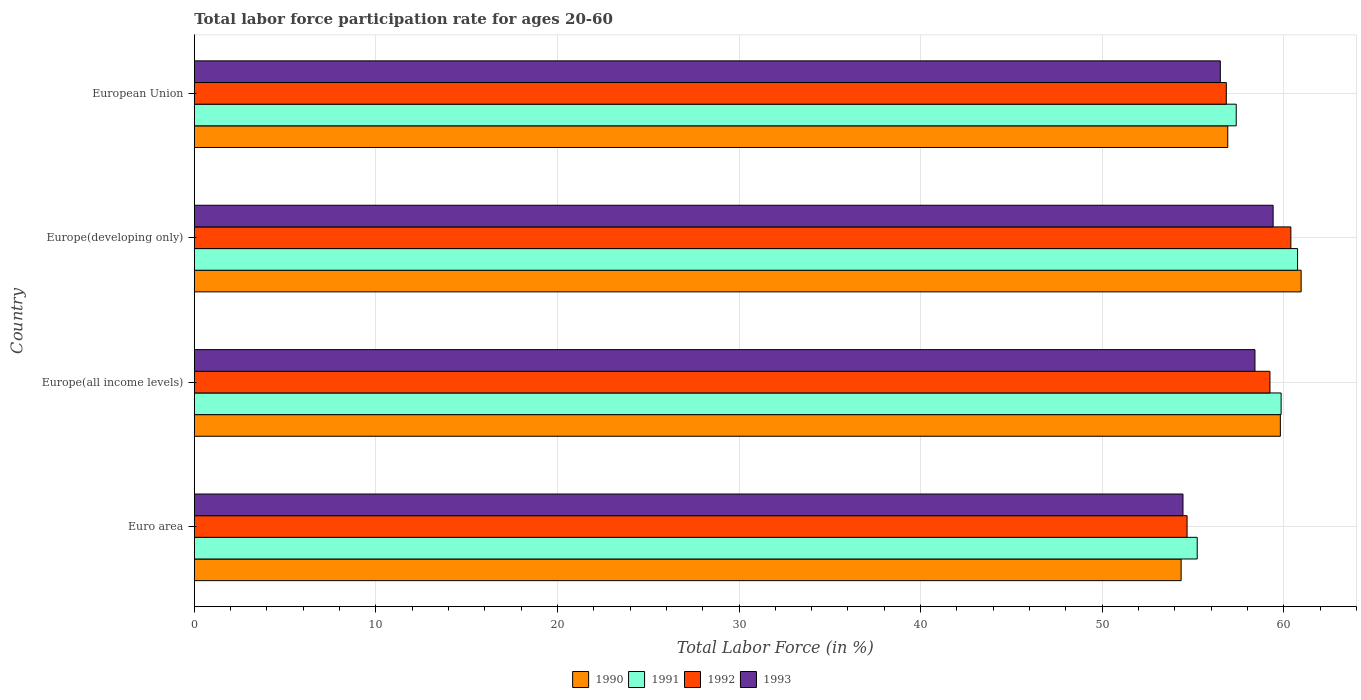Are the number of bars per tick equal to the number of legend labels?
Your response must be concise. Yes. How many bars are there on the 4th tick from the bottom?
Ensure brevity in your answer.  4. What is the label of the 3rd group of bars from the top?
Offer a very short reply. Europe(all income levels). What is the labor force participation rate in 1990 in Europe(all income levels)?
Ensure brevity in your answer.  59.82. Across all countries, what is the maximum labor force participation rate in 1991?
Make the answer very short. 60.76. Across all countries, what is the minimum labor force participation rate in 1991?
Keep it short and to the point. 55.24. In which country was the labor force participation rate in 1992 maximum?
Offer a very short reply. Europe(developing only). What is the total labor force participation rate in 1991 in the graph?
Offer a terse response. 233.24. What is the difference between the labor force participation rate in 1992 in Europe(all income levels) and that in European Union?
Your response must be concise. 2.4. What is the difference between the labor force participation rate in 1991 in Euro area and the labor force participation rate in 1993 in Europe(all income levels)?
Keep it short and to the point. -3.18. What is the average labor force participation rate in 1990 per country?
Keep it short and to the point. 58.01. What is the difference between the labor force participation rate in 1991 and labor force participation rate in 1990 in Euro area?
Provide a succinct answer. 0.89. What is the ratio of the labor force participation rate in 1991 in Euro area to that in Europe(developing only)?
Provide a succinct answer. 0.91. What is the difference between the highest and the second highest labor force participation rate in 1993?
Your answer should be very brief. 1. What is the difference between the highest and the lowest labor force participation rate in 1991?
Your response must be concise. 5.53. In how many countries, is the labor force participation rate in 1991 greater than the average labor force participation rate in 1991 taken over all countries?
Your response must be concise. 2. What does the 2nd bar from the bottom in Europe(all income levels) represents?
Offer a terse response. 1991. How many countries are there in the graph?
Your answer should be very brief. 4. What is the difference between two consecutive major ticks on the X-axis?
Offer a very short reply. 10. Does the graph contain any zero values?
Give a very brief answer. No. How many legend labels are there?
Offer a terse response. 4. What is the title of the graph?
Provide a succinct answer. Total labor force participation rate for ages 20-60. What is the label or title of the X-axis?
Your answer should be very brief. Total Labor Force (in %). What is the label or title of the Y-axis?
Offer a terse response. Country. What is the Total Labor Force (in %) in 1990 in Euro area?
Your answer should be very brief. 54.35. What is the Total Labor Force (in %) in 1991 in Euro area?
Your answer should be very brief. 55.24. What is the Total Labor Force (in %) of 1992 in Euro area?
Your response must be concise. 54.68. What is the Total Labor Force (in %) of 1993 in Euro area?
Provide a short and direct response. 54.45. What is the Total Labor Force (in %) in 1990 in Europe(all income levels)?
Offer a terse response. 59.82. What is the Total Labor Force (in %) of 1991 in Europe(all income levels)?
Offer a terse response. 59.86. What is the Total Labor Force (in %) of 1992 in Europe(all income levels)?
Offer a very short reply. 59.24. What is the Total Labor Force (in %) of 1993 in Europe(all income levels)?
Provide a short and direct response. 58.42. What is the Total Labor Force (in %) in 1990 in Europe(developing only)?
Your response must be concise. 60.96. What is the Total Labor Force (in %) of 1991 in Europe(developing only)?
Keep it short and to the point. 60.76. What is the Total Labor Force (in %) of 1992 in Europe(developing only)?
Your answer should be compact. 60.39. What is the Total Labor Force (in %) of 1993 in Europe(developing only)?
Offer a very short reply. 59.42. What is the Total Labor Force (in %) of 1990 in European Union?
Your response must be concise. 56.92. What is the Total Labor Force (in %) in 1991 in European Union?
Your answer should be very brief. 57.38. What is the Total Labor Force (in %) of 1992 in European Union?
Provide a short and direct response. 56.84. What is the Total Labor Force (in %) of 1993 in European Union?
Provide a succinct answer. 56.51. Across all countries, what is the maximum Total Labor Force (in %) in 1990?
Offer a terse response. 60.96. Across all countries, what is the maximum Total Labor Force (in %) of 1991?
Make the answer very short. 60.76. Across all countries, what is the maximum Total Labor Force (in %) of 1992?
Offer a terse response. 60.39. Across all countries, what is the maximum Total Labor Force (in %) in 1993?
Provide a succinct answer. 59.42. Across all countries, what is the minimum Total Labor Force (in %) of 1990?
Provide a short and direct response. 54.35. Across all countries, what is the minimum Total Labor Force (in %) of 1991?
Ensure brevity in your answer.  55.24. Across all countries, what is the minimum Total Labor Force (in %) in 1992?
Keep it short and to the point. 54.68. Across all countries, what is the minimum Total Labor Force (in %) of 1993?
Provide a succinct answer. 54.45. What is the total Total Labor Force (in %) in 1990 in the graph?
Ensure brevity in your answer.  232.04. What is the total Total Labor Force (in %) in 1991 in the graph?
Your response must be concise. 233.24. What is the total Total Labor Force (in %) in 1992 in the graph?
Offer a very short reply. 231.15. What is the total Total Labor Force (in %) of 1993 in the graph?
Give a very brief answer. 228.79. What is the difference between the Total Labor Force (in %) of 1990 in Euro area and that in Europe(all income levels)?
Your answer should be compact. -5.46. What is the difference between the Total Labor Force (in %) in 1991 in Euro area and that in Europe(all income levels)?
Make the answer very short. -4.62. What is the difference between the Total Labor Force (in %) of 1992 in Euro area and that in Europe(all income levels)?
Offer a terse response. -4.56. What is the difference between the Total Labor Force (in %) in 1993 in Euro area and that in Europe(all income levels)?
Give a very brief answer. -3.96. What is the difference between the Total Labor Force (in %) of 1990 in Euro area and that in Europe(developing only)?
Your response must be concise. -6.61. What is the difference between the Total Labor Force (in %) of 1991 in Euro area and that in Europe(developing only)?
Keep it short and to the point. -5.53. What is the difference between the Total Labor Force (in %) of 1992 in Euro area and that in Europe(developing only)?
Offer a very short reply. -5.72. What is the difference between the Total Labor Force (in %) in 1993 in Euro area and that in Europe(developing only)?
Offer a terse response. -4.96. What is the difference between the Total Labor Force (in %) in 1990 in Euro area and that in European Union?
Your response must be concise. -2.57. What is the difference between the Total Labor Force (in %) in 1991 in Euro area and that in European Union?
Ensure brevity in your answer.  -2.15. What is the difference between the Total Labor Force (in %) of 1992 in Euro area and that in European Union?
Provide a short and direct response. -2.16. What is the difference between the Total Labor Force (in %) of 1993 in Euro area and that in European Union?
Keep it short and to the point. -2.06. What is the difference between the Total Labor Force (in %) in 1990 in Europe(all income levels) and that in Europe(developing only)?
Ensure brevity in your answer.  -1.14. What is the difference between the Total Labor Force (in %) of 1991 in Europe(all income levels) and that in Europe(developing only)?
Give a very brief answer. -0.91. What is the difference between the Total Labor Force (in %) in 1992 in Europe(all income levels) and that in Europe(developing only)?
Your response must be concise. -1.15. What is the difference between the Total Labor Force (in %) of 1993 in Europe(all income levels) and that in Europe(developing only)?
Give a very brief answer. -1. What is the difference between the Total Labor Force (in %) of 1990 in Europe(all income levels) and that in European Union?
Provide a short and direct response. 2.9. What is the difference between the Total Labor Force (in %) of 1991 in Europe(all income levels) and that in European Union?
Ensure brevity in your answer.  2.47. What is the difference between the Total Labor Force (in %) of 1992 in Europe(all income levels) and that in European Union?
Make the answer very short. 2.4. What is the difference between the Total Labor Force (in %) of 1993 in Europe(all income levels) and that in European Union?
Ensure brevity in your answer.  1.91. What is the difference between the Total Labor Force (in %) of 1990 in Europe(developing only) and that in European Union?
Offer a very short reply. 4.04. What is the difference between the Total Labor Force (in %) of 1991 in Europe(developing only) and that in European Union?
Offer a very short reply. 3.38. What is the difference between the Total Labor Force (in %) of 1992 in Europe(developing only) and that in European Union?
Your answer should be very brief. 3.56. What is the difference between the Total Labor Force (in %) in 1993 in Europe(developing only) and that in European Union?
Your response must be concise. 2.91. What is the difference between the Total Labor Force (in %) in 1990 in Euro area and the Total Labor Force (in %) in 1991 in Europe(all income levels)?
Offer a very short reply. -5.51. What is the difference between the Total Labor Force (in %) in 1990 in Euro area and the Total Labor Force (in %) in 1992 in Europe(all income levels)?
Ensure brevity in your answer.  -4.89. What is the difference between the Total Labor Force (in %) of 1990 in Euro area and the Total Labor Force (in %) of 1993 in Europe(all income levels)?
Give a very brief answer. -4.07. What is the difference between the Total Labor Force (in %) of 1991 in Euro area and the Total Labor Force (in %) of 1992 in Europe(all income levels)?
Make the answer very short. -4.01. What is the difference between the Total Labor Force (in %) in 1991 in Euro area and the Total Labor Force (in %) in 1993 in Europe(all income levels)?
Your response must be concise. -3.18. What is the difference between the Total Labor Force (in %) in 1992 in Euro area and the Total Labor Force (in %) in 1993 in Europe(all income levels)?
Your answer should be compact. -3.74. What is the difference between the Total Labor Force (in %) in 1990 in Euro area and the Total Labor Force (in %) in 1991 in Europe(developing only)?
Make the answer very short. -6.41. What is the difference between the Total Labor Force (in %) in 1990 in Euro area and the Total Labor Force (in %) in 1992 in Europe(developing only)?
Your response must be concise. -6.04. What is the difference between the Total Labor Force (in %) of 1990 in Euro area and the Total Labor Force (in %) of 1993 in Europe(developing only)?
Keep it short and to the point. -5.07. What is the difference between the Total Labor Force (in %) in 1991 in Euro area and the Total Labor Force (in %) in 1992 in Europe(developing only)?
Provide a short and direct response. -5.16. What is the difference between the Total Labor Force (in %) of 1991 in Euro area and the Total Labor Force (in %) of 1993 in Europe(developing only)?
Your response must be concise. -4.18. What is the difference between the Total Labor Force (in %) in 1992 in Euro area and the Total Labor Force (in %) in 1993 in Europe(developing only)?
Offer a very short reply. -4.74. What is the difference between the Total Labor Force (in %) in 1990 in Euro area and the Total Labor Force (in %) in 1991 in European Union?
Keep it short and to the point. -3.03. What is the difference between the Total Labor Force (in %) in 1990 in Euro area and the Total Labor Force (in %) in 1992 in European Union?
Offer a very short reply. -2.49. What is the difference between the Total Labor Force (in %) in 1990 in Euro area and the Total Labor Force (in %) in 1993 in European Union?
Ensure brevity in your answer.  -2.16. What is the difference between the Total Labor Force (in %) in 1991 in Euro area and the Total Labor Force (in %) in 1992 in European Union?
Offer a very short reply. -1.6. What is the difference between the Total Labor Force (in %) in 1991 in Euro area and the Total Labor Force (in %) in 1993 in European Union?
Ensure brevity in your answer.  -1.27. What is the difference between the Total Labor Force (in %) in 1992 in Euro area and the Total Labor Force (in %) in 1993 in European Union?
Your answer should be very brief. -1.83. What is the difference between the Total Labor Force (in %) in 1990 in Europe(all income levels) and the Total Labor Force (in %) in 1991 in Europe(developing only)?
Give a very brief answer. -0.95. What is the difference between the Total Labor Force (in %) of 1990 in Europe(all income levels) and the Total Labor Force (in %) of 1992 in Europe(developing only)?
Your response must be concise. -0.58. What is the difference between the Total Labor Force (in %) in 1990 in Europe(all income levels) and the Total Labor Force (in %) in 1993 in Europe(developing only)?
Ensure brevity in your answer.  0.4. What is the difference between the Total Labor Force (in %) of 1991 in Europe(all income levels) and the Total Labor Force (in %) of 1992 in Europe(developing only)?
Offer a terse response. -0.54. What is the difference between the Total Labor Force (in %) in 1991 in Europe(all income levels) and the Total Labor Force (in %) in 1993 in Europe(developing only)?
Your response must be concise. 0.44. What is the difference between the Total Labor Force (in %) in 1992 in Europe(all income levels) and the Total Labor Force (in %) in 1993 in Europe(developing only)?
Provide a succinct answer. -0.17. What is the difference between the Total Labor Force (in %) in 1990 in Europe(all income levels) and the Total Labor Force (in %) in 1991 in European Union?
Your answer should be compact. 2.43. What is the difference between the Total Labor Force (in %) of 1990 in Europe(all income levels) and the Total Labor Force (in %) of 1992 in European Union?
Your response must be concise. 2.98. What is the difference between the Total Labor Force (in %) in 1990 in Europe(all income levels) and the Total Labor Force (in %) in 1993 in European Union?
Provide a succinct answer. 3.31. What is the difference between the Total Labor Force (in %) of 1991 in Europe(all income levels) and the Total Labor Force (in %) of 1992 in European Union?
Ensure brevity in your answer.  3.02. What is the difference between the Total Labor Force (in %) in 1991 in Europe(all income levels) and the Total Labor Force (in %) in 1993 in European Union?
Your answer should be compact. 3.35. What is the difference between the Total Labor Force (in %) in 1992 in Europe(all income levels) and the Total Labor Force (in %) in 1993 in European Union?
Offer a very short reply. 2.73. What is the difference between the Total Labor Force (in %) of 1990 in Europe(developing only) and the Total Labor Force (in %) of 1991 in European Union?
Ensure brevity in your answer.  3.57. What is the difference between the Total Labor Force (in %) in 1990 in Europe(developing only) and the Total Labor Force (in %) in 1992 in European Union?
Provide a short and direct response. 4.12. What is the difference between the Total Labor Force (in %) in 1990 in Europe(developing only) and the Total Labor Force (in %) in 1993 in European Union?
Your answer should be compact. 4.45. What is the difference between the Total Labor Force (in %) in 1991 in Europe(developing only) and the Total Labor Force (in %) in 1992 in European Union?
Offer a terse response. 3.93. What is the difference between the Total Labor Force (in %) of 1991 in Europe(developing only) and the Total Labor Force (in %) of 1993 in European Union?
Your answer should be very brief. 4.25. What is the difference between the Total Labor Force (in %) of 1992 in Europe(developing only) and the Total Labor Force (in %) of 1993 in European Union?
Your answer should be very brief. 3.88. What is the average Total Labor Force (in %) in 1990 per country?
Offer a very short reply. 58.01. What is the average Total Labor Force (in %) in 1991 per country?
Make the answer very short. 58.31. What is the average Total Labor Force (in %) in 1992 per country?
Give a very brief answer. 57.79. What is the average Total Labor Force (in %) in 1993 per country?
Keep it short and to the point. 57.2. What is the difference between the Total Labor Force (in %) in 1990 and Total Labor Force (in %) in 1991 in Euro area?
Your answer should be compact. -0.89. What is the difference between the Total Labor Force (in %) of 1990 and Total Labor Force (in %) of 1992 in Euro area?
Provide a short and direct response. -0.33. What is the difference between the Total Labor Force (in %) of 1990 and Total Labor Force (in %) of 1993 in Euro area?
Your answer should be very brief. -0.1. What is the difference between the Total Labor Force (in %) of 1991 and Total Labor Force (in %) of 1992 in Euro area?
Ensure brevity in your answer.  0.56. What is the difference between the Total Labor Force (in %) in 1991 and Total Labor Force (in %) in 1993 in Euro area?
Offer a terse response. 0.78. What is the difference between the Total Labor Force (in %) in 1992 and Total Labor Force (in %) in 1993 in Euro area?
Your answer should be very brief. 0.22. What is the difference between the Total Labor Force (in %) in 1990 and Total Labor Force (in %) in 1991 in Europe(all income levels)?
Provide a succinct answer. -0.04. What is the difference between the Total Labor Force (in %) in 1990 and Total Labor Force (in %) in 1992 in Europe(all income levels)?
Ensure brevity in your answer.  0.57. What is the difference between the Total Labor Force (in %) in 1990 and Total Labor Force (in %) in 1993 in Europe(all income levels)?
Give a very brief answer. 1.4. What is the difference between the Total Labor Force (in %) in 1991 and Total Labor Force (in %) in 1992 in Europe(all income levels)?
Your answer should be compact. 0.61. What is the difference between the Total Labor Force (in %) in 1991 and Total Labor Force (in %) in 1993 in Europe(all income levels)?
Your answer should be compact. 1.44. What is the difference between the Total Labor Force (in %) in 1992 and Total Labor Force (in %) in 1993 in Europe(all income levels)?
Ensure brevity in your answer.  0.83. What is the difference between the Total Labor Force (in %) of 1990 and Total Labor Force (in %) of 1991 in Europe(developing only)?
Offer a terse response. 0.2. What is the difference between the Total Labor Force (in %) of 1990 and Total Labor Force (in %) of 1992 in Europe(developing only)?
Give a very brief answer. 0.57. What is the difference between the Total Labor Force (in %) in 1990 and Total Labor Force (in %) in 1993 in Europe(developing only)?
Make the answer very short. 1.54. What is the difference between the Total Labor Force (in %) of 1991 and Total Labor Force (in %) of 1992 in Europe(developing only)?
Provide a succinct answer. 0.37. What is the difference between the Total Labor Force (in %) of 1991 and Total Labor Force (in %) of 1993 in Europe(developing only)?
Your answer should be very brief. 1.35. What is the difference between the Total Labor Force (in %) in 1992 and Total Labor Force (in %) in 1993 in Europe(developing only)?
Give a very brief answer. 0.98. What is the difference between the Total Labor Force (in %) in 1990 and Total Labor Force (in %) in 1991 in European Union?
Provide a succinct answer. -0.47. What is the difference between the Total Labor Force (in %) in 1990 and Total Labor Force (in %) in 1992 in European Union?
Ensure brevity in your answer.  0.08. What is the difference between the Total Labor Force (in %) of 1990 and Total Labor Force (in %) of 1993 in European Union?
Offer a very short reply. 0.41. What is the difference between the Total Labor Force (in %) of 1991 and Total Labor Force (in %) of 1992 in European Union?
Provide a succinct answer. 0.55. What is the difference between the Total Labor Force (in %) in 1991 and Total Labor Force (in %) in 1993 in European Union?
Provide a short and direct response. 0.88. What is the difference between the Total Labor Force (in %) of 1992 and Total Labor Force (in %) of 1993 in European Union?
Provide a short and direct response. 0.33. What is the ratio of the Total Labor Force (in %) of 1990 in Euro area to that in Europe(all income levels)?
Offer a terse response. 0.91. What is the ratio of the Total Labor Force (in %) of 1991 in Euro area to that in Europe(all income levels)?
Offer a very short reply. 0.92. What is the ratio of the Total Labor Force (in %) of 1992 in Euro area to that in Europe(all income levels)?
Your response must be concise. 0.92. What is the ratio of the Total Labor Force (in %) of 1993 in Euro area to that in Europe(all income levels)?
Your answer should be very brief. 0.93. What is the ratio of the Total Labor Force (in %) in 1990 in Euro area to that in Europe(developing only)?
Your answer should be compact. 0.89. What is the ratio of the Total Labor Force (in %) in 1991 in Euro area to that in Europe(developing only)?
Keep it short and to the point. 0.91. What is the ratio of the Total Labor Force (in %) of 1992 in Euro area to that in Europe(developing only)?
Make the answer very short. 0.91. What is the ratio of the Total Labor Force (in %) of 1993 in Euro area to that in Europe(developing only)?
Your response must be concise. 0.92. What is the ratio of the Total Labor Force (in %) in 1990 in Euro area to that in European Union?
Provide a succinct answer. 0.95. What is the ratio of the Total Labor Force (in %) in 1991 in Euro area to that in European Union?
Offer a very short reply. 0.96. What is the ratio of the Total Labor Force (in %) in 1992 in Euro area to that in European Union?
Offer a terse response. 0.96. What is the ratio of the Total Labor Force (in %) of 1993 in Euro area to that in European Union?
Make the answer very short. 0.96. What is the ratio of the Total Labor Force (in %) in 1990 in Europe(all income levels) to that in Europe(developing only)?
Your response must be concise. 0.98. What is the ratio of the Total Labor Force (in %) of 1991 in Europe(all income levels) to that in Europe(developing only)?
Give a very brief answer. 0.99. What is the ratio of the Total Labor Force (in %) in 1992 in Europe(all income levels) to that in Europe(developing only)?
Your response must be concise. 0.98. What is the ratio of the Total Labor Force (in %) of 1993 in Europe(all income levels) to that in Europe(developing only)?
Offer a terse response. 0.98. What is the ratio of the Total Labor Force (in %) of 1990 in Europe(all income levels) to that in European Union?
Make the answer very short. 1.05. What is the ratio of the Total Labor Force (in %) of 1991 in Europe(all income levels) to that in European Union?
Your answer should be very brief. 1.04. What is the ratio of the Total Labor Force (in %) in 1992 in Europe(all income levels) to that in European Union?
Make the answer very short. 1.04. What is the ratio of the Total Labor Force (in %) in 1993 in Europe(all income levels) to that in European Union?
Provide a short and direct response. 1.03. What is the ratio of the Total Labor Force (in %) of 1990 in Europe(developing only) to that in European Union?
Give a very brief answer. 1.07. What is the ratio of the Total Labor Force (in %) of 1991 in Europe(developing only) to that in European Union?
Give a very brief answer. 1.06. What is the ratio of the Total Labor Force (in %) of 1992 in Europe(developing only) to that in European Union?
Make the answer very short. 1.06. What is the ratio of the Total Labor Force (in %) in 1993 in Europe(developing only) to that in European Union?
Your answer should be very brief. 1.05. What is the difference between the highest and the second highest Total Labor Force (in %) in 1990?
Your response must be concise. 1.14. What is the difference between the highest and the second highest Total Labor Force (in %) in 1991?
Your answer should be compact. 0.91. What is the difference between the highest and the second highest Total Labor Force (in %) in 1992?
Provide a succinct answer. 1.15. What is the difference between the highest and the lowest Total Labor Force (in %) in 1990?
Make the answer very short. 6.61. What is the difference between the highest and the lowest Total Labor Force (in %) in 1991?
Offer a terse response. 5.53. What is the difference between the highest and the lowest Total Labor Force (in %) in 1992?
Provide a short and direct response. 5.72. What is the difference between the highest and the lowest Total Labor Force (in %) of 1993?
Your answer should be very brief. 4.96. 